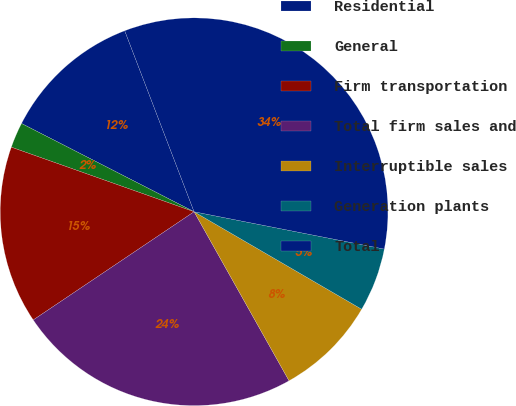<chart> <loc_0><loc_0><loc_500><loc_500><pie_chart><fcel>Residential<fcel>General<fcel>Firm transportation<fcel>Total firm sales and<fcel>Interruptible sales<fcel>Generation plants<fcel>Total<nl><fcel>11.65%<fcel>2.12%<fcel>14.83%<fcel>23.72%<fcel>8.47%<fcel>5.3%<fcel>33.91%<nl></chart> 